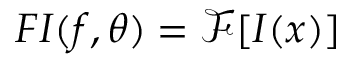<formula> <loc_0><loc_0><loc_500><loc_500>F I ( f , \theta ) = \mathcal { F } [ I ( x ) ]</formula> 